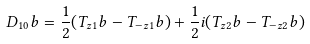Convert formula to latex. <formula><loc_0><loc_0><loc_500><loc_500>D _ { 1 0 } b = \frac { 1 } { 2 } ( T _ { z 1 } b - T _ { - z 1 } b ) + \frac { 1 } { 2 } i ( T _ { z 2 } b - T _ { - z 2 } b )</formula> 